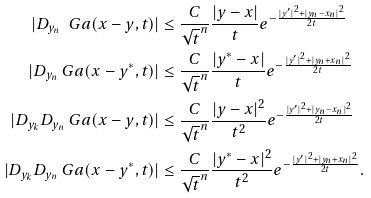Convert formula to latex. <formula><loc_0><loc_0><loc_500><loc_500>| D _ { y _ { n } } \ G a ( x - y , t ) | & \leq \frac { C } { \sqrt { t } ^ { n } } \frac { | y - x | } { t } e ^ { - \frac { | y ^ { \prime } | ^ { 2 } + | y _ { n } - x _ { n } | ^ { 2 } } { 2 t } } \\ | D _ { y _ { n } } \ G a ( x - y ^ { * } , t ) | & \leq \frac { C } { \sqrt { t } ^ { n } } \frac { | y ^ { * } - x | } { t } e ^ { - \frac { | y ^ { \prime } | ^ { 2 } + | y _ { n } + x _ { n } | ^ { 2 } } { 2 t } } \\ | D _ { y _ { k } } D _ { y _ { n } } \ G a ( x - y , t ) | & \leq \frac { C } { \sqrt { t } ^ { n } } \frac { | y - x | ^ { 2 } } { t ^ { 2 } } e ^ { - \frac { | y ^ { \prime } | ^ { 2 } + | y _ { n } - x _ { n } | ^ { 2 } } { 2 t } } \\ | D _ { y _ { k } } D _ { y _ { n } } \ G a ( x - y ^ { * } , t ) | & \leq \frac { C } { \sqrt { t } ^ { n } } \frac { | y ^ { * } - x | ^ { 2 } } { t ^ { 2 } } e ^ { - \frac { | y ^ { \prime } | ^ { 2 } + | y _ { n } + x _ { n } | ^ { 2 } } { 2 t } } .</formula> 